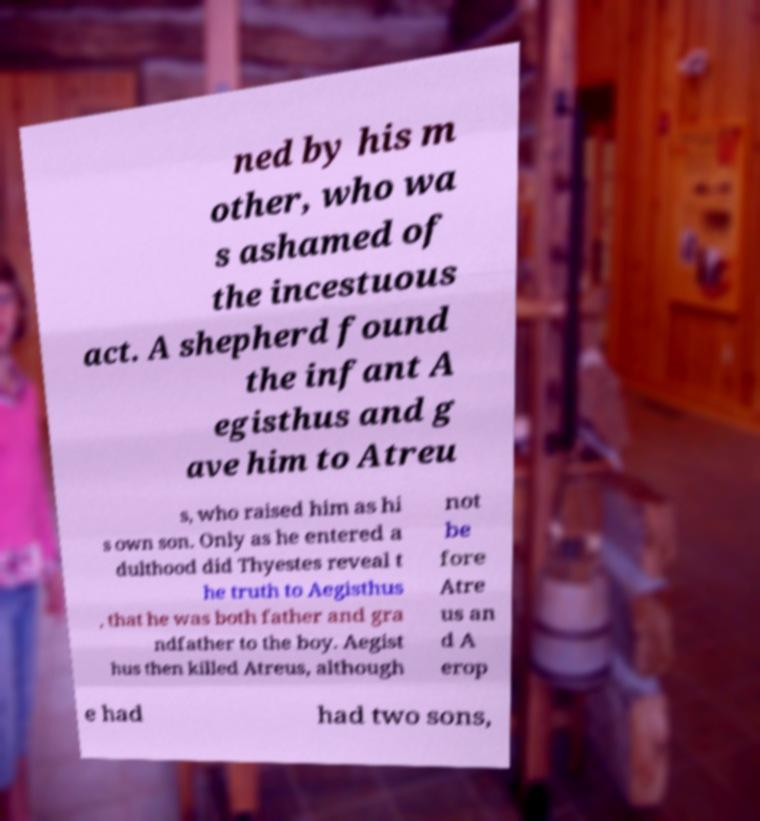There's text embedded in this image that I need extracted. Can you transcribe it verbatim? ned by his m other, who wa s ashamed of the incestuous act. A shepherd found the infant A egisthus and g ave him to Atreu s, who raised him as hi s own son. Only as he entered a dulthood did Thyestes reveal t he truth to Aegisthus , that he was both father and gra ndfather to the boy. Aegist hus then killed Atreus, although not be fore Atre us an d A erop e had had two sons, 